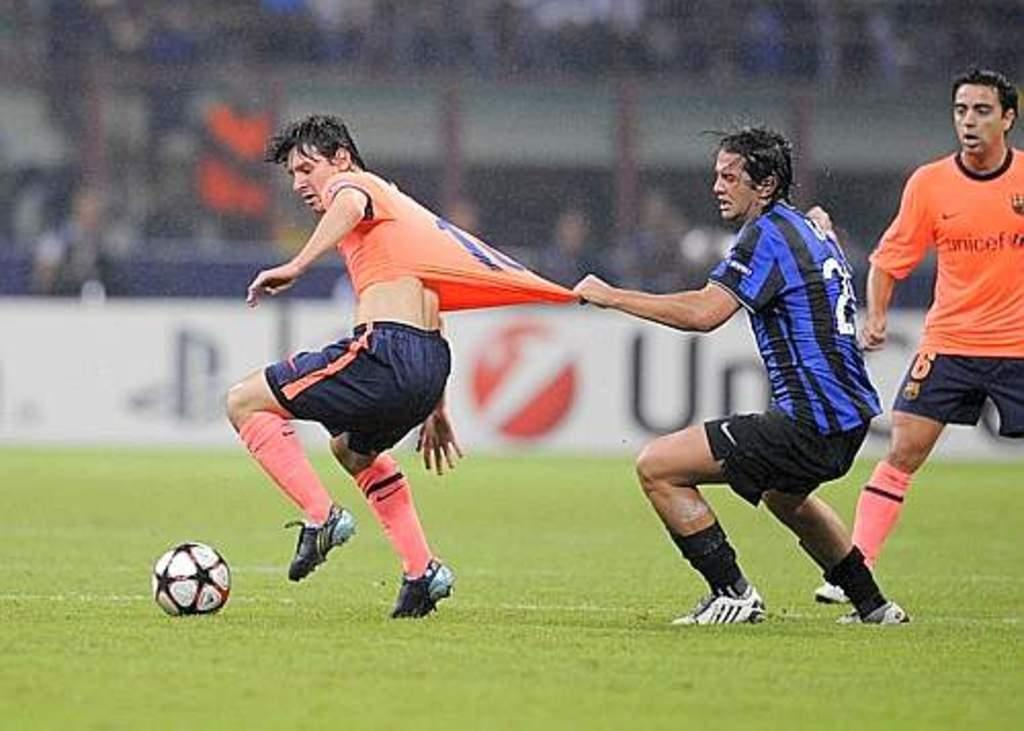What can be observed about the background of the image? The background portion of the picture is blurry. What object is present in the image that might be used for displaying information or instructions? There is a board visible in the image. Who or what is participating in the activity shown in the image? There are players in the image. What object is being used by the players in the image? There is a ball in the image. What color is the ground in the image? The ground has a green carpet. Can you tell me how many times the players have moved their wings during the game? There are no wings present in the image, as the players are likely participating in a sport that does not involve wings. 